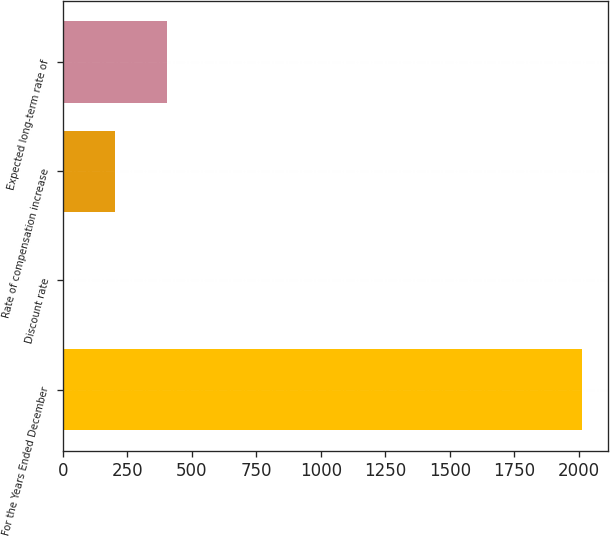<chart> <loc_0><loc_0><loc_500><loc_500><bar_chart><fcel>For the Years Ended December<fcel>Discount rate<fcel>Rate of compensation increase<fcel>Expected long-term rate of<nl><fcel>2013<fcel>2.13<fcel>203.22<fcel>404.31<nl></chart> 